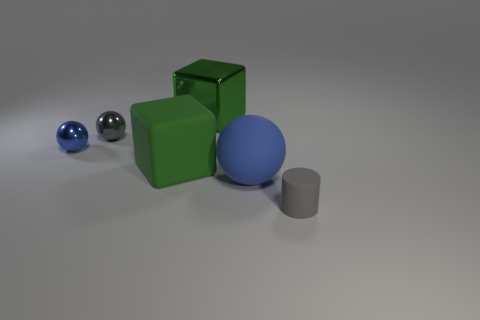Is there any other thing that has the same size as the green rubber block?
Keep it short and to the point. Yes. What color is the ball that is behind the thing left of the tiny gray thing to the left of the small rubber cylinder?
Ensure brevity in your answer.  Gray. Are there any other green metal things of the same shape as the large green metallic thing?
Provide a short and direct response. No. Are there an equal number of large green shiny cubes right of the big blue rubber object and big rubber balls left of the tiny blue thing?
Your response must be concise. Yes. There is a blue thing that is right of the gray metallic ball; does it have the same shape as the green metallic object?
Offer a terse response. No. Is the blue matte thing the same shape as the big green matte thing?
Give a very brief answer. No. What number of shiny objects are either large green cubes or spheres?
Your answer should be very brief. 3. There is a sphere that is the same color as the small rubber cylinder; what material is it?
Your answer should be very brief. Metal. Is the size of the blue matte thing the same as the green rubber object?
Ensure brevity in your answer.  Yes. What number of objects are cyan cubes or small objects to the right of the small blue sphere?
Ensure brevity in your answer.  2. 